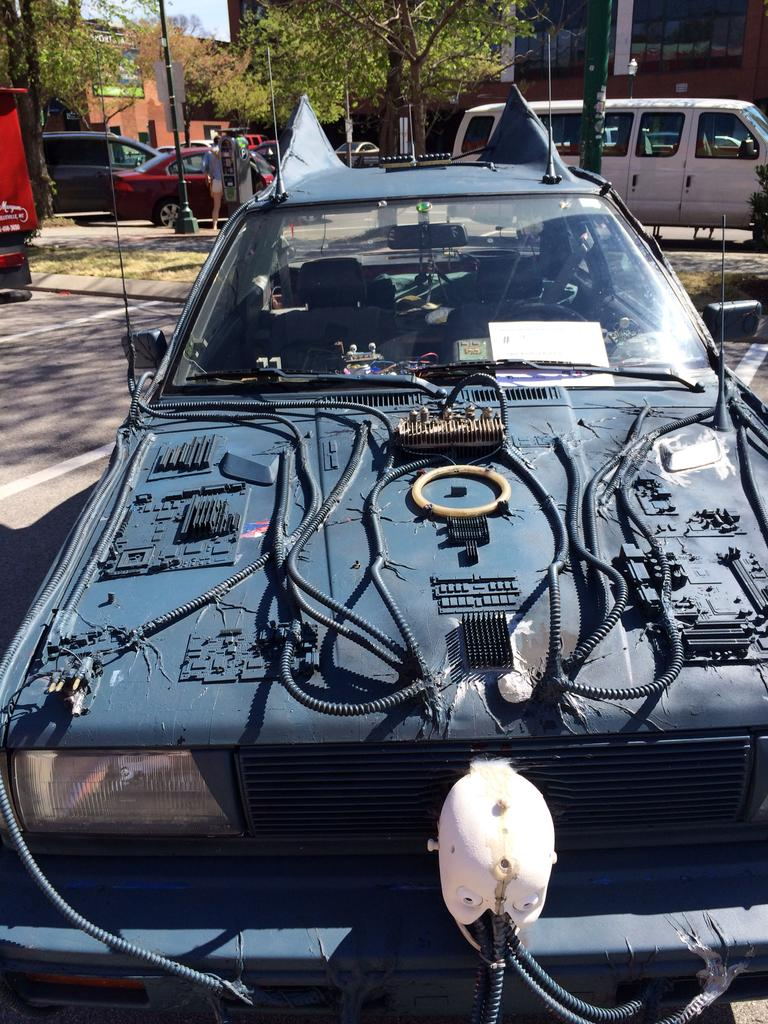What color is the car in the image? The car in the image is black. What can be seen in the background of the image? Trees and buildings are visible in the background of the image. Are there any other cars in the image? Yes, there are cars in the background of the image. What type of ear is visible on the car in the image? There are no ears present on the car in the image, as cars do not have ears. What color is the paint used on the trees in the image? The trees in the image are not painted, so there is no paint color to describe. 